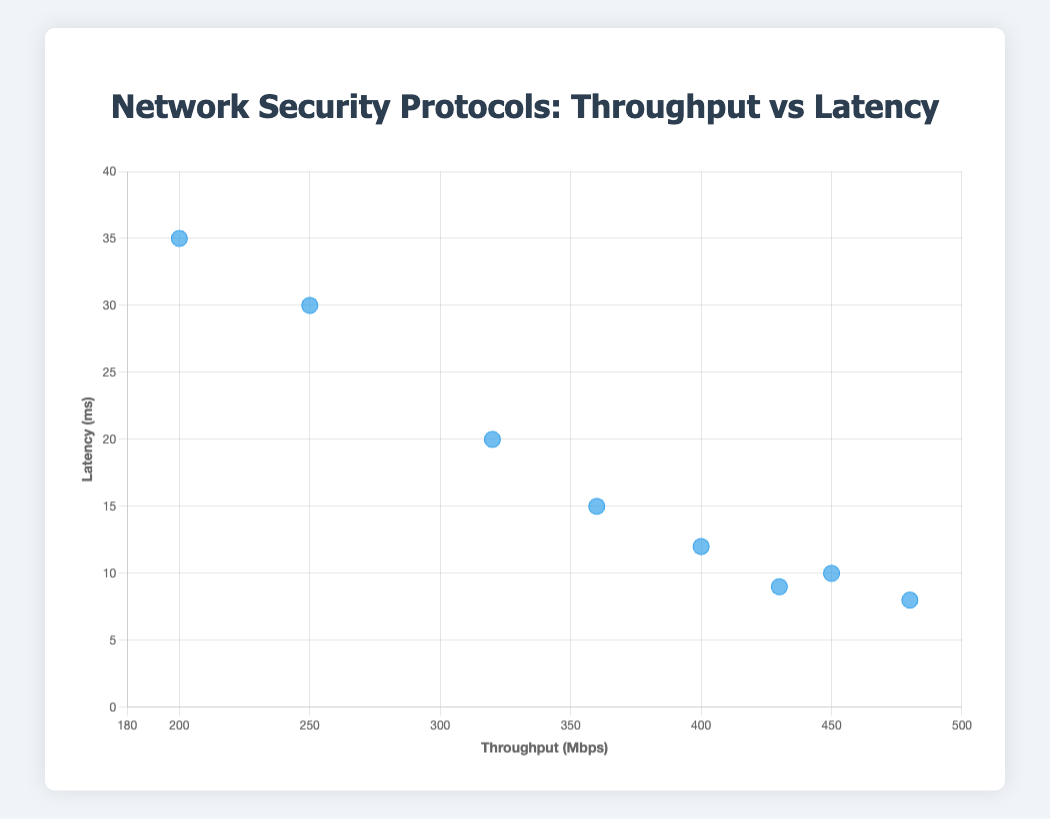How many different protocols are represented in the scatter plot? The scatter plot features one point for each different protocol. By counting the number of different data points, we see that there are eight protocols.
Answer: Eight protocols What is the title of the plot? The title of the plot is displayed at the top of the figure, and it reads: "Network Security Protocols: Throughput vs Latency."
Answer: Network Security Protocols: Throughput vs Latency Which protocol has the highest throughput, and what is its corresponding latency? By looking at the x-axis for the highest throughput and identifying the protocol, we find that "TLS 1.3" has the highest throughput of 480 Mbps, with a corresponding latency of 8 ms.
Answer: TLS 1.3; 8 ms Which protocol has the lowest latency? By examining the y-axis for the lowest latency and identifying the protocol associated with this point, we see "TLS 1.3" has the lowest latency at 8 ms.
Answer: TLS 1.3 Are there any protocols that have both below 400 Mbps throughput and above 20 ms latency? By analyzing the plot for points that have lower than 400 Mbps throughput on the x-axis and higher than 20 ms latency on the y-axis, we identify that "SSL 3.0" meets this criteria.
Answer: SSL 3.0 Which protocol has the highest latency and what is its throughput? By searching for the point at the highest position on the y-axis and noting the protocol, "SSL 2.0" has the highest latency at 35 ms, with a throughput of 200 Mbps.
Answer: SSL 2.0; 200 Mbps Which protocol shows moderate performance with throughput around 400 Mbps and latency around 15 ms? Observing the scatter plot for a data point near 400 Mbps on the x-axis and around 15 ms on the y-axis, "IKEv2" fits this description with 400 Mbps throughput and 12 ms latency.
Answer: IKEv2 By how much does the throughput of "TLS 1.2" exceed that of "IPsec"? The throughput of "TLS 1.2" is 450 Mbps, and that of "IPsec" is 320 Mbps. The difference is calculated by subtracting 320 from 450, which equals 130 Mbps.
Answer: 130 Mbps If you average the latency of "OpenVPN" and "DTLS 1.2," what is the result? The latency of "OpenVPN" is 9 ms, and "DTLS 1.2" is 15 ms. Averaging these values involves adding them together (9 + 15 = 24) and then dividing by 2, resulting in 12 ms.
Answer: 12 ms Which protocol has better performance overall if we consider both high throughput and low latency? "TLS 1.3" has the highest throughput at 480 Mbps and the lowest latency at 8 ms, making it the best performing overall in terms of high throughput and low latency.
Answer: TLS 1.3 